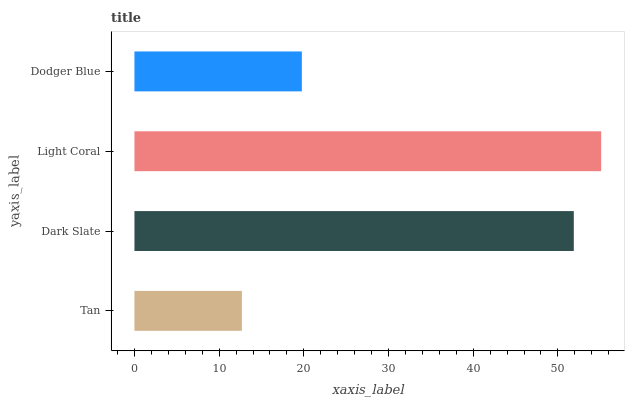Is Tan the minimum?
Answer yes or no. Yes. Is Light Coral the maximum?
Answer yes or no. Yes. Is Dark Slate the minimum?
Answer yes or no. No. Is Dark Slate the maximum?
Answer yes or no. No. Is Dark Slate greater than Tan?
Answer yes or no. Yes. Is Tan less than Dark Slate?
Answer yes or no. Yes. Is Tan greater than Dark Slate?
Answer yes or no. No. Is Dark Slate less than Tan?
Answer yes or no. No. Is Dark Slate the high median?
Answer yes or no. Yes. Is Dodger Blue the low median?
Answer yes or no. Yes. Is Dodger Blue the high median?
Answer yes or no. No. Is Light Coral the low median?
Answer yes or no. No. 